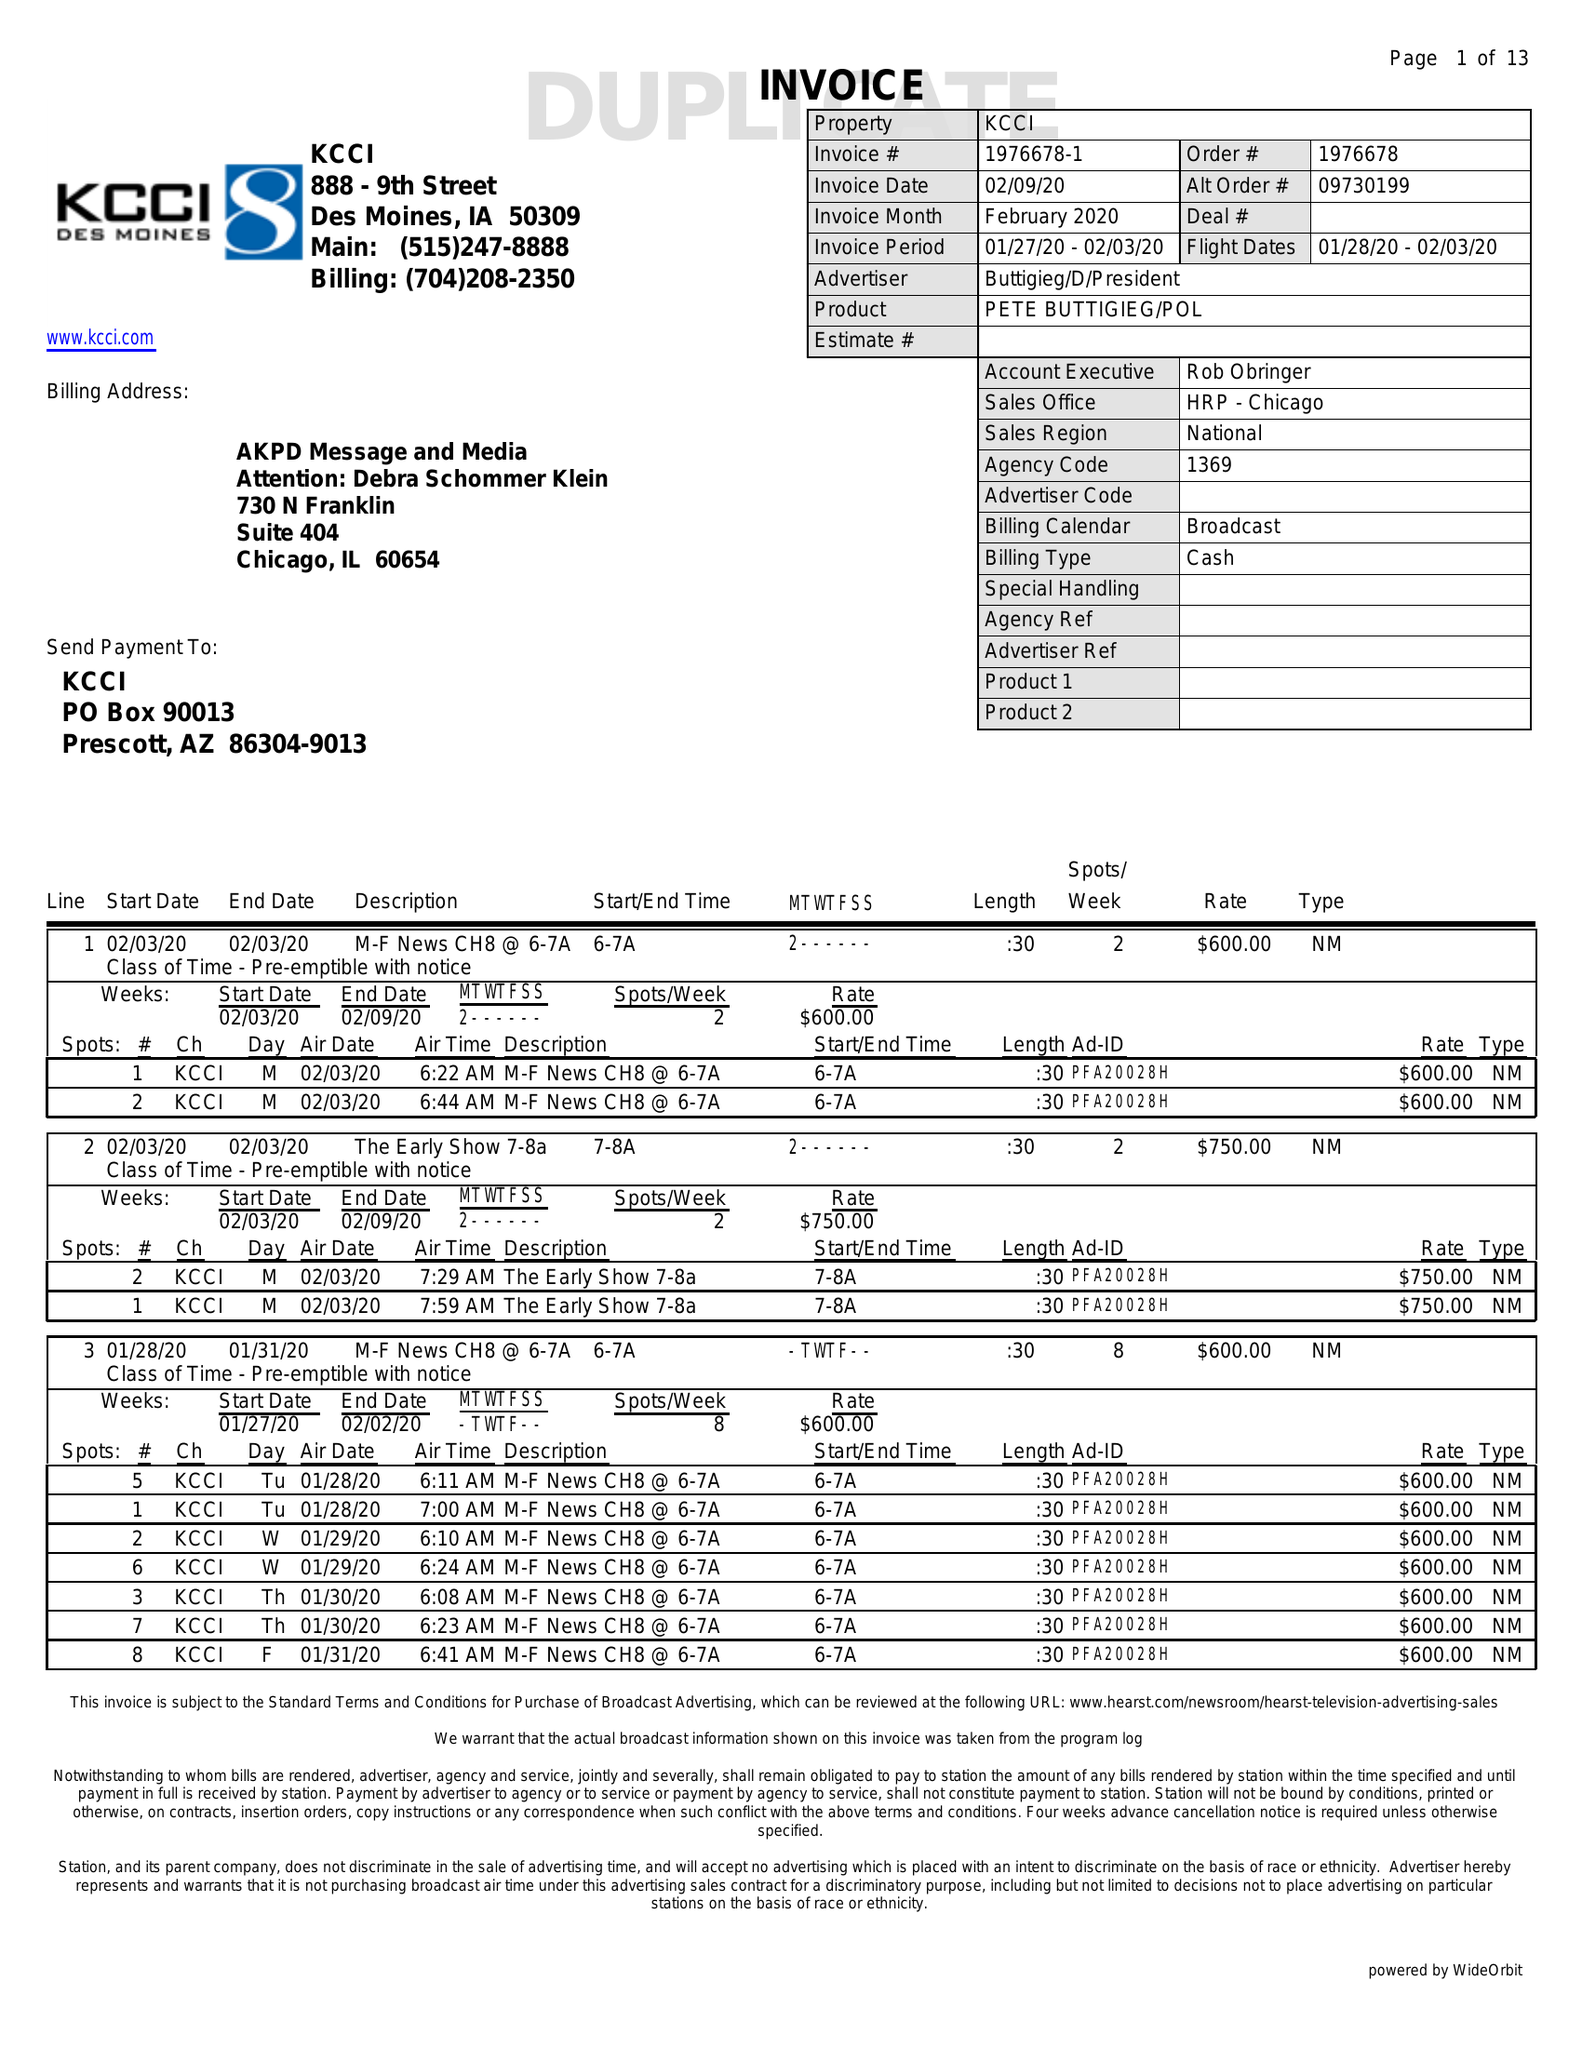What is the value for the advertiser?
Answer the question using a single word or phrase. BUTTIGIEG/D/PRESIDENT 